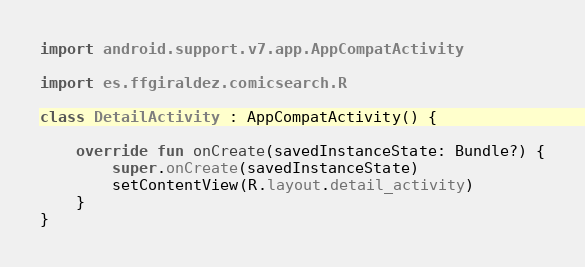Convert code to text. <code><loc_0><loc_0><loc_500><loc_500><_Kotlin_>import android.support.v7.app.AppCompatActivity

import es.ffgiraldez.comicsearch.R

class DetailActivity : AppCompatActivity() {

    override fun onCreate(savedInstanceState: Bundle?) {
        super.onCreate(savedInstanceState)
        setContentView(R.layout.detail_activity)
    }
}
</code> 